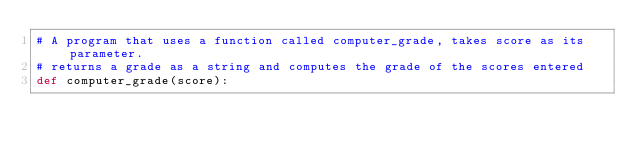<code> <loc_0><loc_0><loc_500><loc_500><_Python_># A program that uses a function called computer_grade, takes score as its parameter.
# returns a grade as a string and computes the grade of the scores entered
def computer_grade(score):</code> 